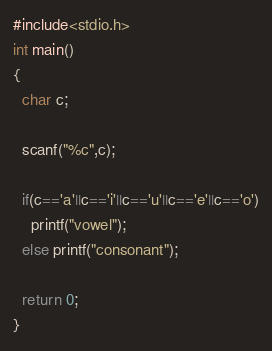<code> <loc_0><loc_0><loc_500><loc_500><_C_>#include<stdio.h>
int main()
{
  char c;
  
  scanf("%c",c);
  
  if(c=='a'||c=='i'||c=='u'||c=='e'||c=='o')
    printf("vowel");
  else printf("consonant");
  
  return 0;
}</code> 